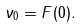<formula> <loc_0><loc_0><loc_500><loc_500>\nu _ { 0 } = F ( 0 ) .</formula> 